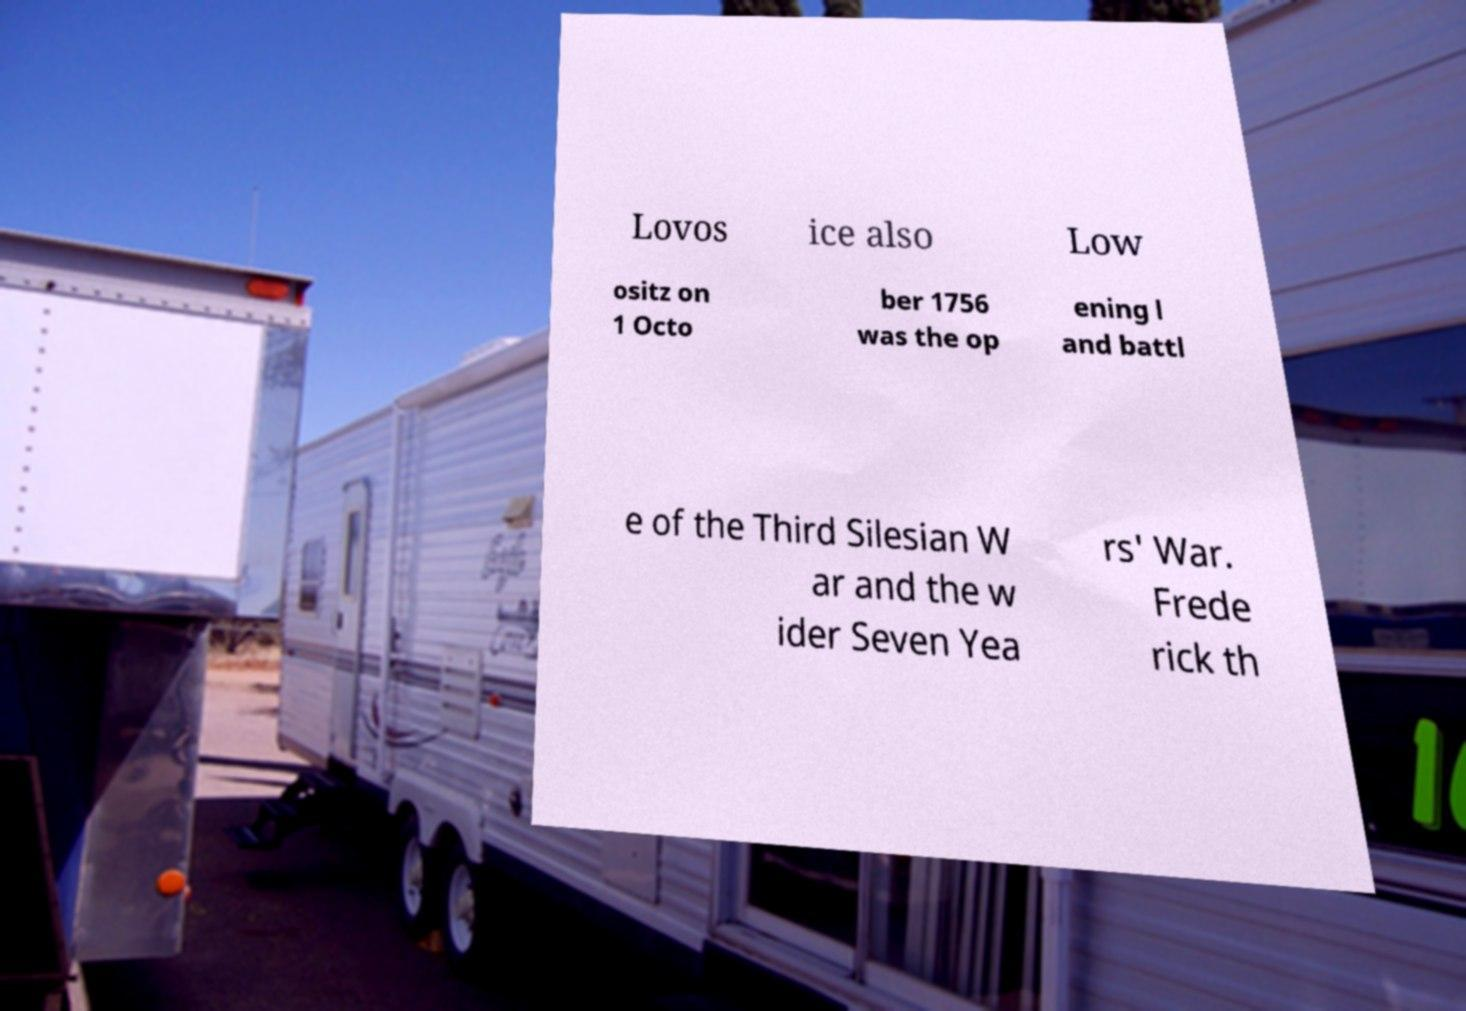Please read and relay the text visible in this image. What does it say? Lovos ice also Low ositz on 1 Octo ber 1756 was the op ening l and battl e of the Third Silesian W ar and the w ider Seven Yea rs' War. Frede rick th 